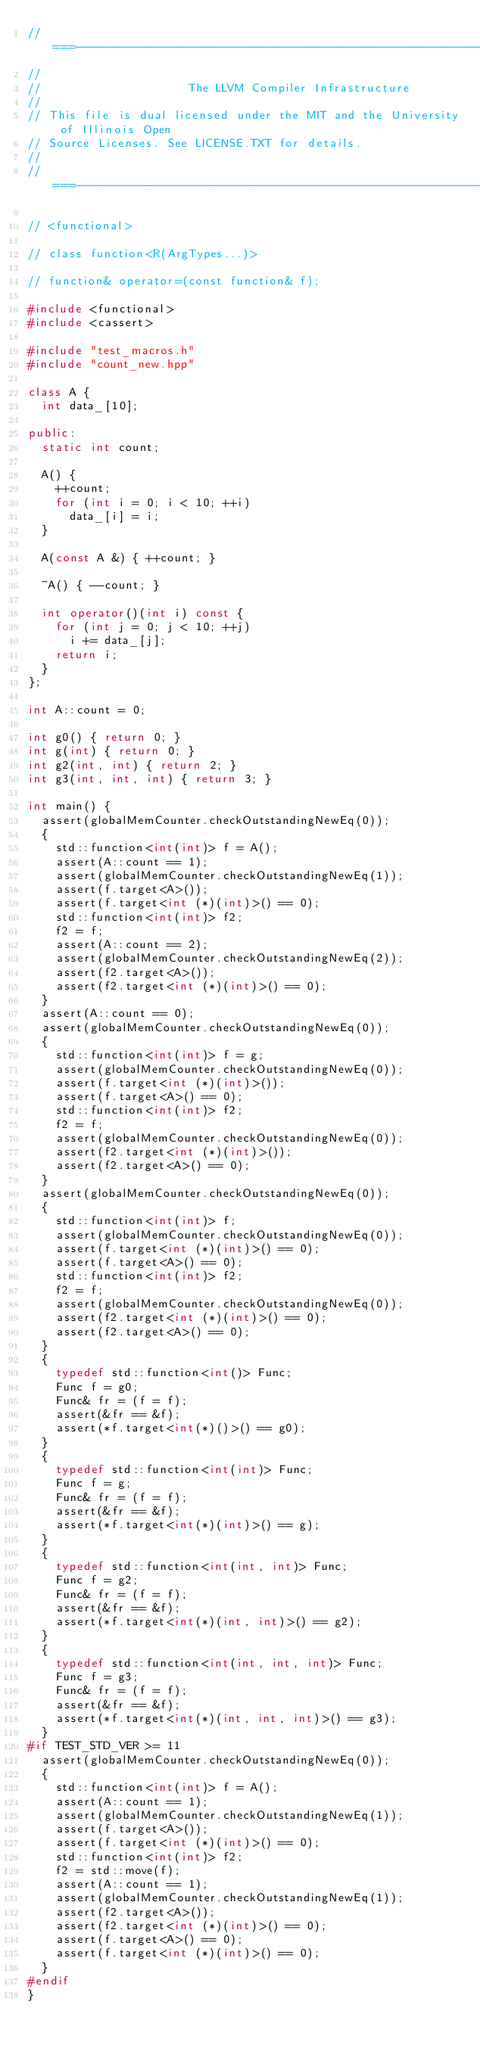Convert code to text. <code><loc_0><loc_0><loc_500><loc_500><_C++_>//===----------------------------------------------------------------------===//
//
//                     The LLVM Compiler Infrastructure
//
// This file is dual licensed under the MIT and the University of Illinois Open
// Source Licenses. See LICENSE.TXT for details.
//
//===----------------------------------------------------------------------===//

// <functional>

// class function<R(ArgTypes...)>

// function& operator=(const function& f);

#include <functional>
#include <cassert>

#include "test_macros.h"
#include "count_new.hpp"

class A {
  int data_[10];

public:
  static int count;

  A() {
    ++count;
    for (int i = 0; i < 10; ++i)
      data_[i] = i;
  }

  A(const A &) { ++count; }

  ~A() { --count; }

  int operator()(int i) const {
    for (int j = 0; j < 10; ++j)
      i += data_[j];
    return i;
  }
};

int A::count = 0;

int g0() { return 0; }
int g(int) { return 0; }
int g2(int, int) { return 2; }
int g3(int, int, int) { return 3; }

int main() {
  assert(globalMemCounter.checkOutstandingNewEq(0));
  {
    std::function<int(int)> f = A();
    assert(A::count == 1);
    assert(globalMemCounter.checkOutstandingNewEq(1));
    assert(f.target<A>());
    assert(f.target<int (*)(int)>() == 0);
    std::function<int(int)> f2;
    f2 = f;
    assert(A::count == 2);
    assert(globalMemCounter.checkOutstandingNewEq(2));
    assert(f2.target<A>());
    assert(f2.target<int (*)(int)>() == 0);
  }
  assert(A::count == 0);
  assert(globalMemCounter.checkOutstandingNewEq(0));
  {
    std::function<int(int)> f = g;
    assert(globalMemCounter.checkOutstandingNewEq(0));
    assert(f.target<int (*)(int)>());
    assert(f.target<A>() == 0);
    std::function<int(int)> f2;
    f2 = f;
    assert(globalMemCounter.checkOutstandingNewEq(0));
    assert(f2.target<int (*)(int)>());
    assert(f2.target<A>() == 0);
  }
  assert(globalMemCounter.checkOutstandingNewEq(0));
  {
    std::function<int(int)> f;
    assert(globalMemCounter.checkOutstandingNewEq(0));
    assert(f.target<int (*)(int)>() == 0);
    assert(f.target<A>() == 0);
    std::function<int(int)> f2;
    f2 = f;
    assert(globalMemCounter.checkOutstandingNewEq(0));
    assert(f2.target<int (*)(int)>() == 0);
    assert(f2.target<A>() == 0);
  }
  {
    typedef std::function<int()> Func;
    Func f = g0;
    Func& fr = (f = f);
    assert(&fr == &f);
    assert(*f.target<int(*)()>() == g0);
  }
  {
    typedef std::function<int(int)> Func;
    Func f = g;
    Func& fr = (f = f);
    assert(&fr == &f);
    assert(*f.target<int(*)(int)>() == g);
  }
  {
    typedef std::function<int(int, int)> Func;
    Func f = g2;
    Func& fr = (f = f);
    assert(&fr == &f);
    assert(*f.target<int(*)(int, int)>() == g2);
  }
  {
    typedef std::function<int(int, int, int)> Func;
    Func f = g3;
    Func& fr = (f = f);
    assert(&fr == &f);
    assert(*f.target<int(*)(int, int, int)>() == g3);
  }
#if TEST_STD_VER >= 11
  assert(globalMemCounter.checkOutstandingNewEq(0));
  {
    std::function<int(int)> f = A();
    assert(A::count == 1);
    assert(globalMemCounter.checkOutstandingNewEq(1));
    assert(f.target<A>());
    assert(f.target<int (*)(int)>() == 0);
    std::function<int(int)> f2;
    f2 = std::move(f);
    assert(A::count == 1);
    assert(globalMemCounter.checkOutstandingNewEq(1));
    assert(f2.target<A>());
    assert(f2.target<int (*)(int)>() == 0);
    assert(f.target<A>() == 0);
    assert(f.target<int (*)(int)>() == 0);
  }
#endif
}
</code> 